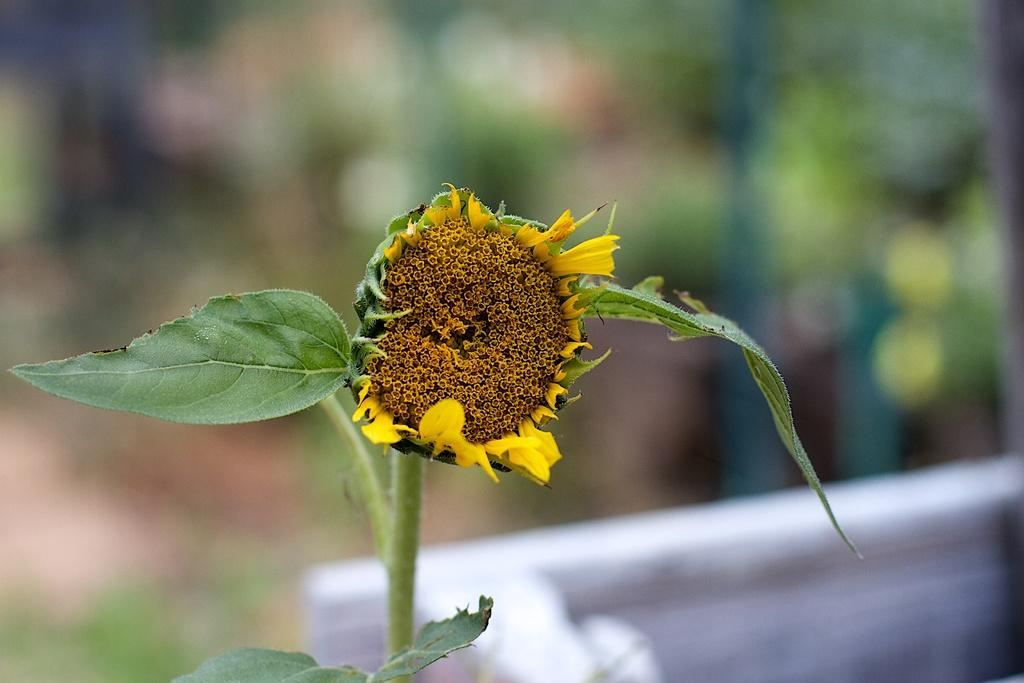What type of plant is visible in the image? There is a plant in the image. What part of the plant is particularly noticeable? There is a flower in the image. What structure is present in the background of the image? There is a wall in the image. How would you describe the background of the image? The background of the image is blurred. What type of cake is being served at the health event in the image? There is no cake or health event present in the image; it features a plant with a flower and a blurred background. What rule is being enforced by the person holding the cake in the image? There is no person holding a cake or any rule being enforced in the image. 